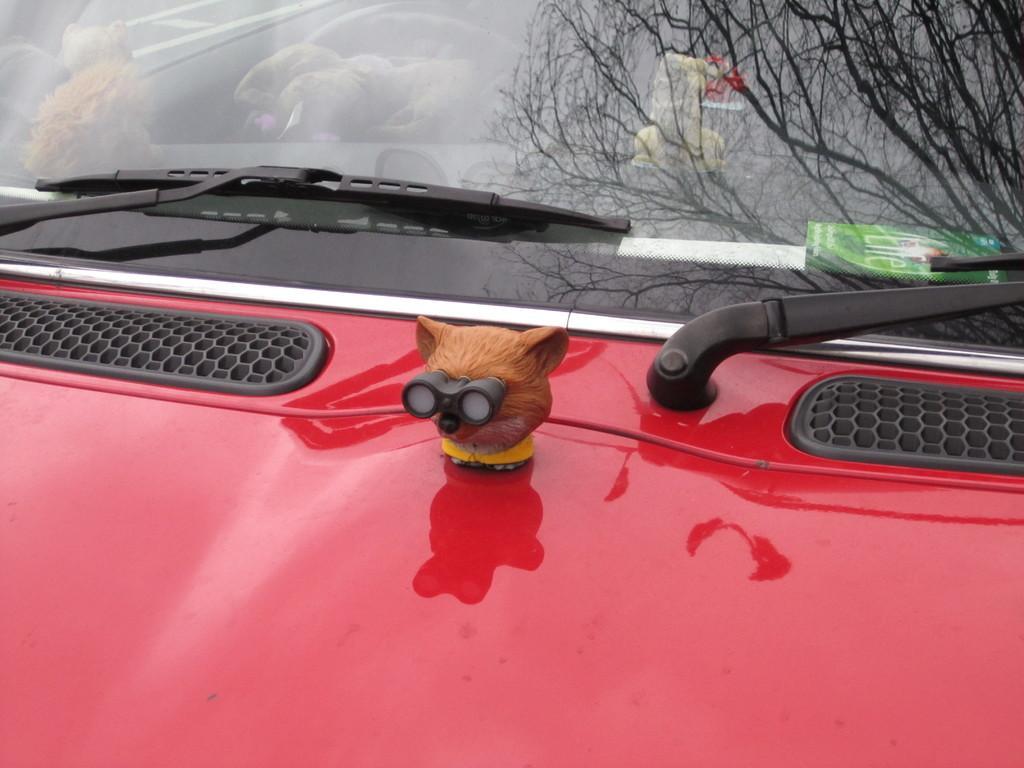Please provide a concise description of this image. In the image we can see a vehicle, red in color. On the vehicle there is a toy and we can even see the reflection of a tree. 